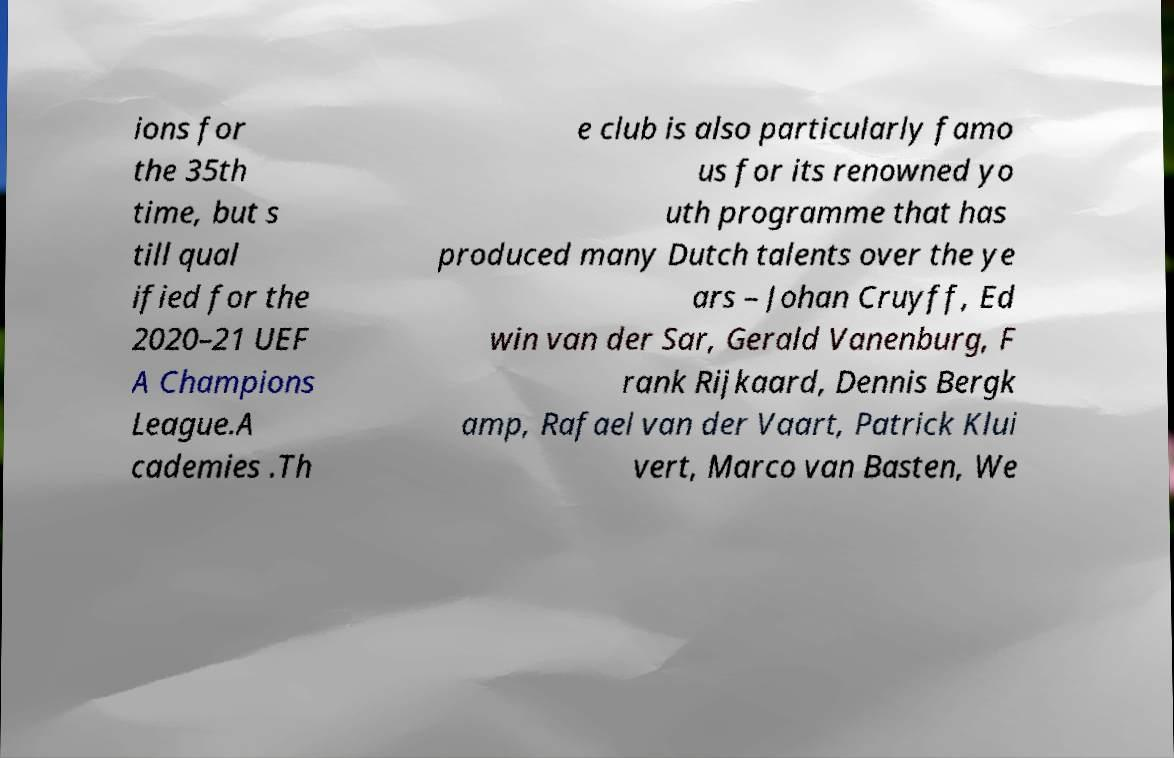Could you extract and type out the text from this image? ions for the 35th time, but s till qual ified for the 2020–21 UEF A Champions League.A cademies .Th e club is also particularly famo us for its renowned yo uth programme that has produced many Dutch talents over the ye ars – Johan Cruyff, Ed win van der Sar, Gerald Vanenburg, F rank Rijkaard, Dennis Bergk amp, Rafael van der Vaart, Patrick Klui vert, Marco van Basten, We 